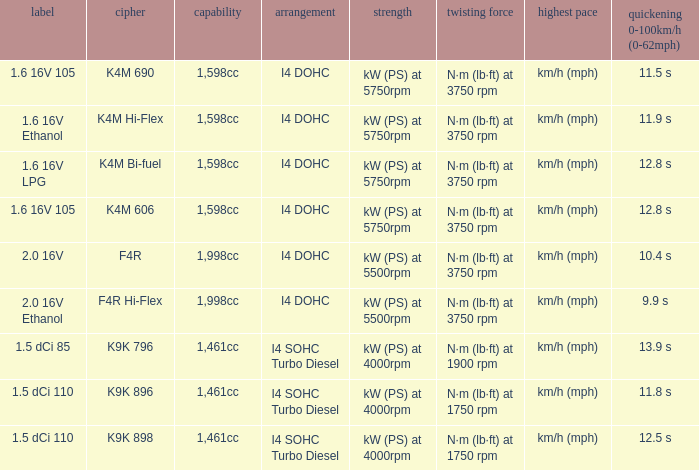Parse the full table. {'header': ['label', 'cipher', 'capability', 'arrangement', 'strength', 'twisting force', 'highest pace', 'quickening 0-100km/h (0-62mph)'], 'rows': [['1.6 16V 105', 'K4M 690', '1,598cc', 'I4 DOHC', 'kW (PS) at 5750rpm', 'N·m (lb·ft) at 3750 rpm', 'km/h (mph)', '11.5 s'], ['1.6 16V Ethanol', 'K4M Hi-Flex', '1,598cc', 'I4 DOHC', 'kW (PS) at 5750rpm', 'N·m (lb·ft) at 3750 rpm', 'km/h (mph)', '11.9 s'], ['1.6 16V LPG', 'K4M Bi-fuel', '1,598cc', 'I4 DOHC', 'kW (PS) at 5750rpm', 'N·m (lb·ft) at 3750 rpm', 'km/h (mph)', '12.8 s'], ['1.6 16V 105', 'K4M 606', '1,598cc', 'I4 DOHC', 'kW (PS) at 5750rpm', 'N·m (lb·ft) at 3750 rpm', 'km/h (mph)', '12.8 s'], ['2.0 16V', 'F4R', '1,998cc', 'I4 DOHC', 'kW (PS) at 5500rpm', 'N·m (lb·ft) at 3750 rpm', 'km/h (mph)', '10.4 s'], ['2.0 16V Ethanol', 'F4R Hi-Flex', '1,998cc', 'I4 DOHC', 'kW (PS) at 5500rpm', 'N·m (lb·ft) at 3750 rpm', 'km/h (mph)', '9.9 s'], ['1.5 dCi 85', 'K9K 796', '1,461cc', 'I4 SOHC Turbo Diesel', 'kW (PS) at 4000rpm', 'N·m (lb·ft) at 1900 rpm', 'km/h (mph)', '13.9 s'], ['1.5 dCi 110', 'K9K 896', '1,461cc', 'I4 SOHC Turbo Diesel', 'kW (PS) at 4000rpm', 'N·m (lb·ft) at 1750 rpm', 'km/h (mph)', '11.8 s'], ['1.5 dCi 110', 'K9K 898', '1,461cc', 'I4 SOHC Turbo Diesel', 'kW (PS) at 4000rpm', 'N·m (lb·ft) at 1750 rpm', 'km/h (mph)', '12.5 s']]} What is the capacity of code f4r? 1,998cc. 